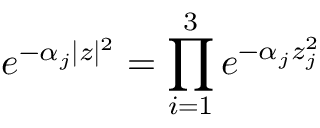<formula> <loc_0><loc_0><loc_500><loc_500>e ^ { - \alpha _ { j } | z | ^ { 2 } } = \prod _ { i = 1 } ^ { 3 } e ^ { - \alpha _ { j } z _ { j } ^ { 2 } }</formula> 